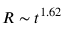Convert formula to latex. <formula><loc_0><loc_0><loc_500><loc_500>R \sim t ^ { 1 . 6 2 }</formula> 